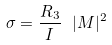Convert formula to latex. <formula><loc_0><loc_0><loc_500><loc_500>\sigma = \frac { R _ { 3 } } { I } \ | M | ^ { 2 }</formula> 